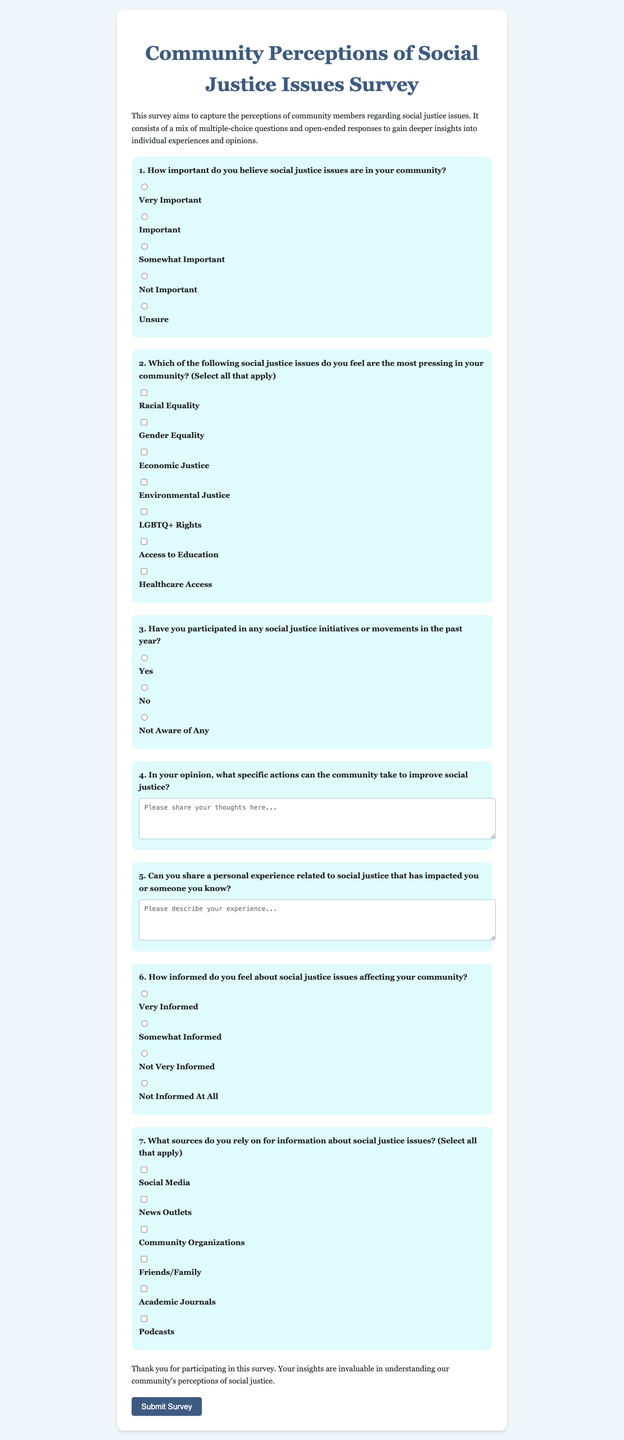what is the title of the survey? The title is presented at the top of the document, indicating the main subject of the survey.
Answer: Community Perceptions of Social Justice Issues Survey how many multiple-choice questions are there in the survey? The survey contains a total of seven multiple-choice questions for respondents to answer.
Answer: 7 what is the value of the first response option for question 1? The first response option is the choice provided for the first question, referring to the importance of social justice issues.
Answer: Very Important which social justice issue is related to healthcare in question 2? This response highlights one of the pressing issues listed in the second question regarding social justice.
Answer: Healthcare Access what is asked in the open-ended response of question 4? This question encourages respondents to provide detailed ideas regarding actions for improving social justice.
Answer: Specific actions can the community take to improve social justice how many sources of information can be selected in question 7? This question inquires about the selection flexibility given in the response options provided in the survey.
Answer: Multiple (select all that apply) what is the color scheme of the survey background? This question examines the overall aesthetic design choice mentioned regarding the survey's visual layout.
Answer: Light blue and white what type of feedback is solicited at the end of the survey? The final statement invites respondents to reflect on their participation's value for community understanding.
Answer: Insights 